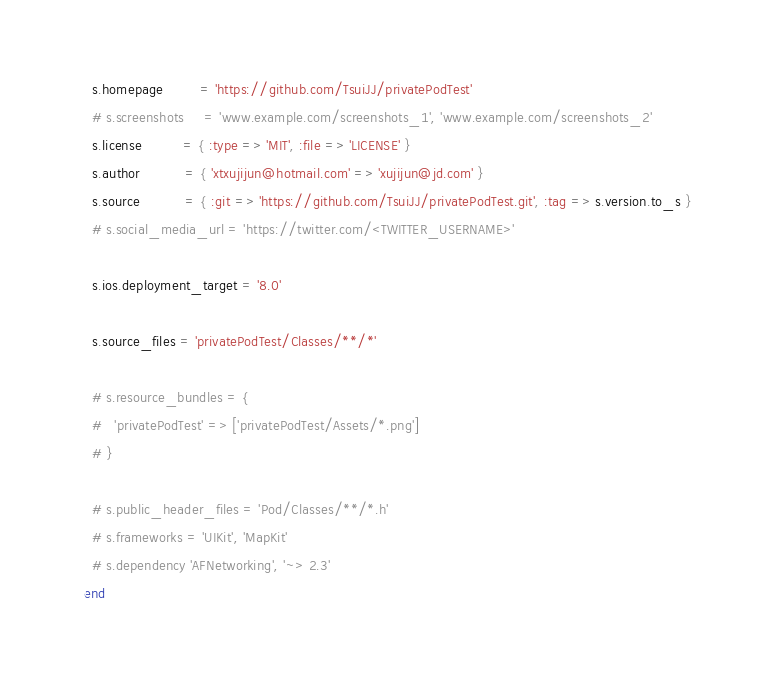Convert code to text. <code><loc_0><loc_0><loc_500><loc_500><_Ruby_>  s.homepage         = 'https://github.com/TsuiJJ/privatePodTest'
  # s.screenshots     = 'www.example.com/screenshots_1', 'www.example.com/screenshots_2'
  s.license          = { :type => 'MIT', :file => 'LICENSE' }
  s.author           = { 'xtxujijun@hotmail.com' => 'xujijun@jd.com' }
  s.source           = { :git => 'https://github.com/TsuiJJ/privatePodTest.git', :tag => s.version.to_s }
  # s.social_media_url = 'https://twitter.com/<TWITTER_USERNAME>'

  s.ios.deployment_target = '8.0'

  s.source_files = 'privatePodTest/Classes/**/*'
  
  # s.resource_bundles = {
  #   'privatePodTest' => ['privatePodTest/Assets/*.png']
  # }

  # s.public_header_files = 'Pod/Classes/**/*.h'
  # s.frameworks = 'UIKit', 'MapKit'
  # s.dependency 'AFNetworking', '~> 2.3'
end
</code> 